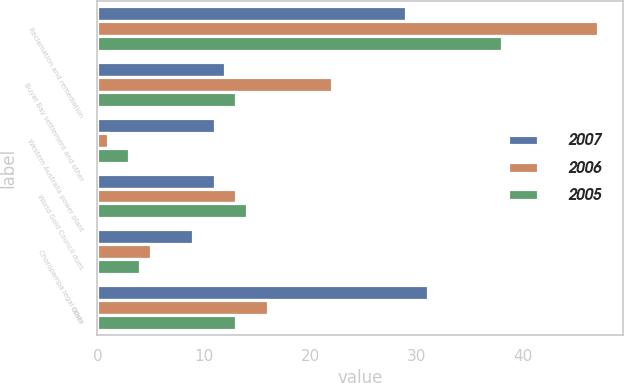<chart> <loc_0><loc_0><loc_500><loc_500><stacked_bar_chart><ecel><fcel>Reclamation and remediation<fcel>Buyat Bay settlement and other<fcel>Western Australia power plant<fcel>World Gold Council dues<fcel>Choropampa legal costs<fcel>Other<nl><fcel>2007<fcel>29<fcel>12<fcel>11<fcel>11<fcel>9<fcel>31<nl><fcel>2006<fcel>47<fcel>22<fcel>1<fcel>13<fcel>5<fcel>16<nl><fcel>2005<fcel>38<fcel>13<fcel>3<fcel>14<fcel>4<fcel>13<nl></chart> 